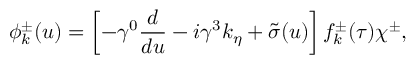Convert formula to latex. <formula><loc_0><loc_0><loc_500><loc_500>\phi _ { k } ^ { \pm } ( u ) = \left [ - \gamma ^ { 0 } { \frac { d } { d u } } - i { \gamma ^ { 3 } } k _ { \eta } + { \tilde { \sigma } } ( u ) \right ] f _ { k } ^ { \pm } ( \tau ) \chi ^ { \pm } ,</formula> 